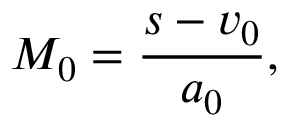Convert formula to latex. <formula><loc_0><loc_0><loc_500><loc_500>M _ { 0 } = \frac { s - v _ { 0 } } { a _ { 0 } } ,</formula> 